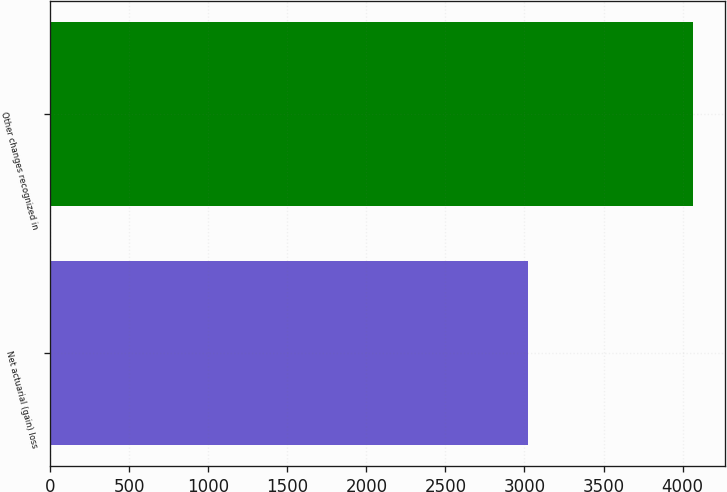Convert chart. <chart><loc_0><loc_0><loc_500><loc_500><bar_chart><fcel>Net actuarial (gain) loss<fcel>Other changes recognized in<nl><fcel>3021<fcel>4067<nl></chart> 